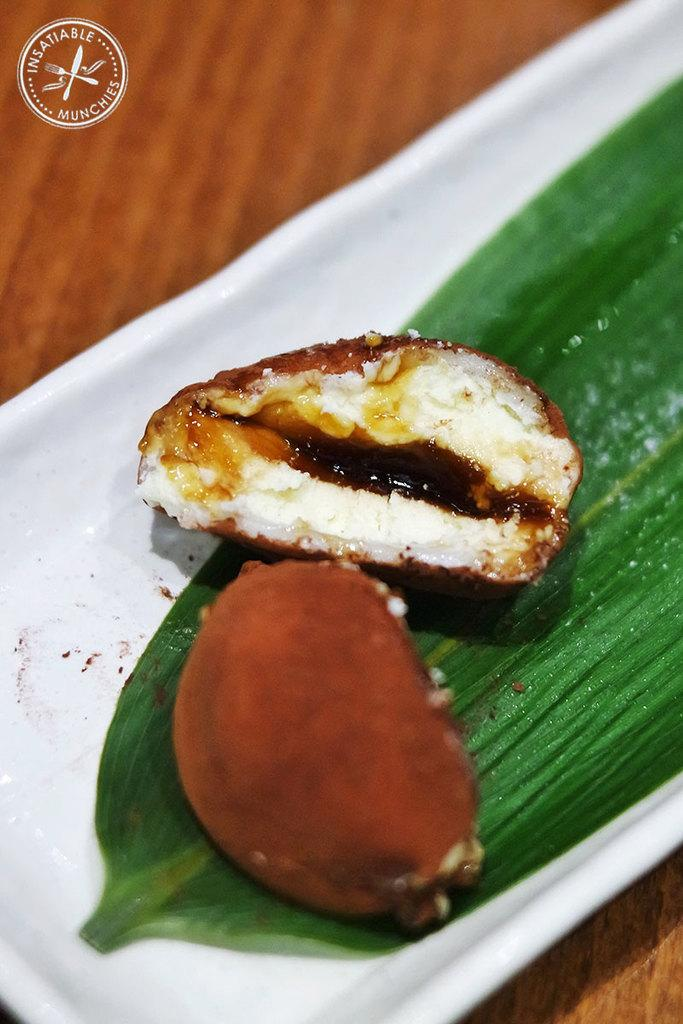What is the main subject of the image? There is a food item in the image. What other object is present in the image? There is a leaf in the image. Where are the food item and leaf placed? The food item and leaf are on a white plate. What is the plate placed on? The plate is kept on a table. Can you describe any additional details about the image? There is a watermark in the top left corner of the image. Is the beast trying to escape from the quicksand in the image? There is no beast or quicksand present in the image. What is the source of shame in the image? There is no shame present in the image; it features a food item, a leaf, and a watermark on a white plate. 